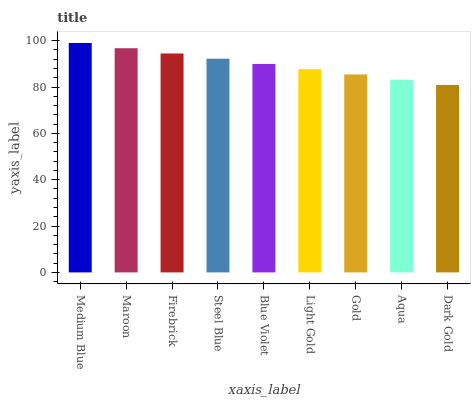Is Dark Gold the minimum?
Answer yes or no. Yes. Is Medium Blue the maximum?
Answer yes or no. Yes. Is Maroon the minimum?
Answer yes or no. No. Is Maroon the maximum?
Answer yes or no. No. Is Medium Blue greater than Maroon?
Answer yes or no. Yes. Is Maroon less than Medium Blue?
Answer yes or no. Yes. Is Maroon greater than Medium Blue?
Answer yes or no. No. Is Medium Blue less than Maroon?
Answer yes or no. No. Is Blue Violet the high median?
Answer yes or no. Yes. Is Blue Violet the low median?
Answer yes or no. Yes. Is Medium Blue the high median?
Answer yes or no. No. Is Firebrick the low median?
Answer yes or no. No. 